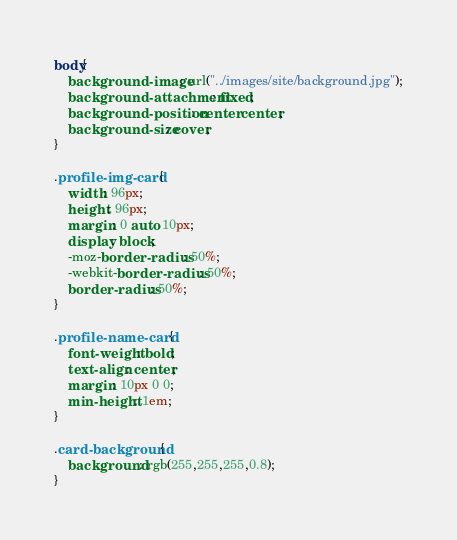Convert code to text. <code><loc_0><loc_0><loc_500><loc_500><_CSS_>body{
    background-image: url("../images/site/background.jpg");
    background-attachment: fixed;
    background-position: center center;
    background-size: cover;
}

.profile-img-card {
    width: 96px;
    height: 96px;
    margin: 0 auto 10px;
    display: block;
    -moz-border-radius: 50%;
    -webkit-border-radius: 50%;
    border-radius: 50%;
}

.profile-name-card {
    font-weight: bold;
    text-align: center;
    margin: 10px 0 0;
    min-height: 1em;
}

.card-background{
    background: rgb(255,255,255,0.8);
}</code> 